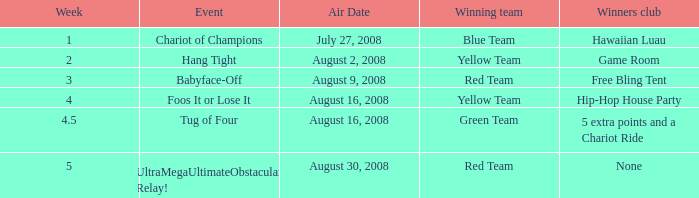How many weeks have a Winning team of yellow team, and an Event of foos it or lose it? 4.0. 